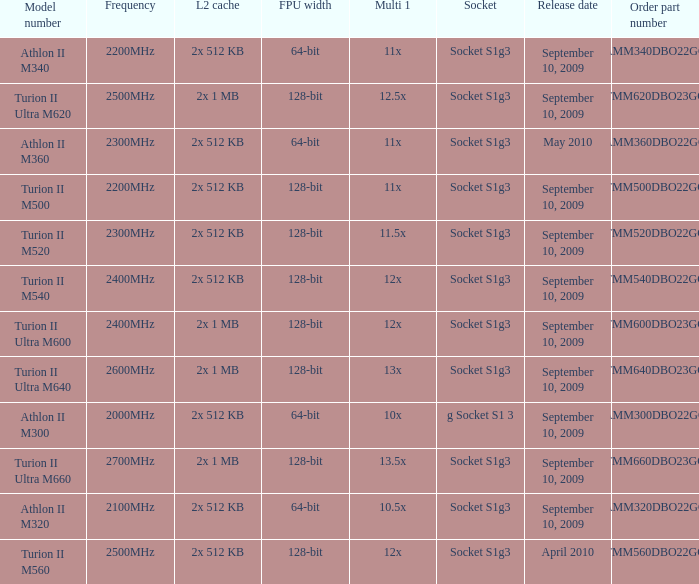What is the order part number with a 12.5x multi 1? TMM620DBO23GQ. 